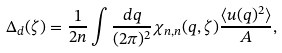<formula> <loc_0><loc_0><loc_500><loc_500>\Delta _ { d } ( \zeta ) = \frac { 1 } { 2 n } \int \frac { d { q } } { ( 2 \pi ) ^ { 2 } } \chi _ { n , n } ( q , \zeta ) \frac { \langle u ( { q } ) ^ { 2 } \rangle } { A } ,</formula> 